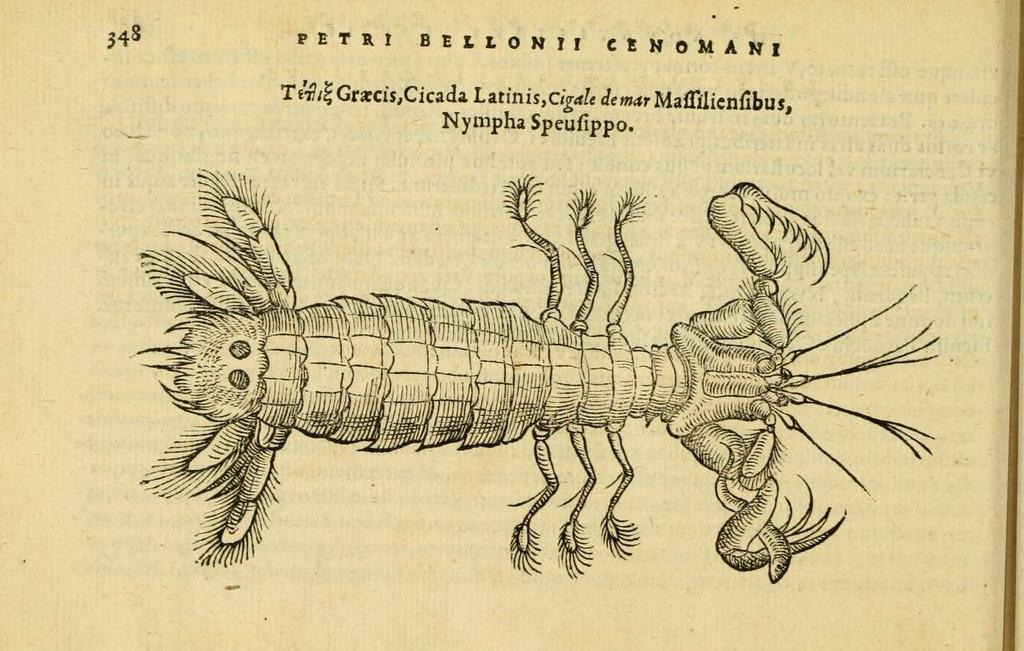What type of creature can be seen in the image? There is an insect in the image. What else is present in the image besides the insect? There is text in the image. What can be inferred about the origin of the image based on the facts? The image appears to be a printed copy of a book. What type of thread is being used to create the sugar trail in the image? There is no thread or sugar trail present in the image. 